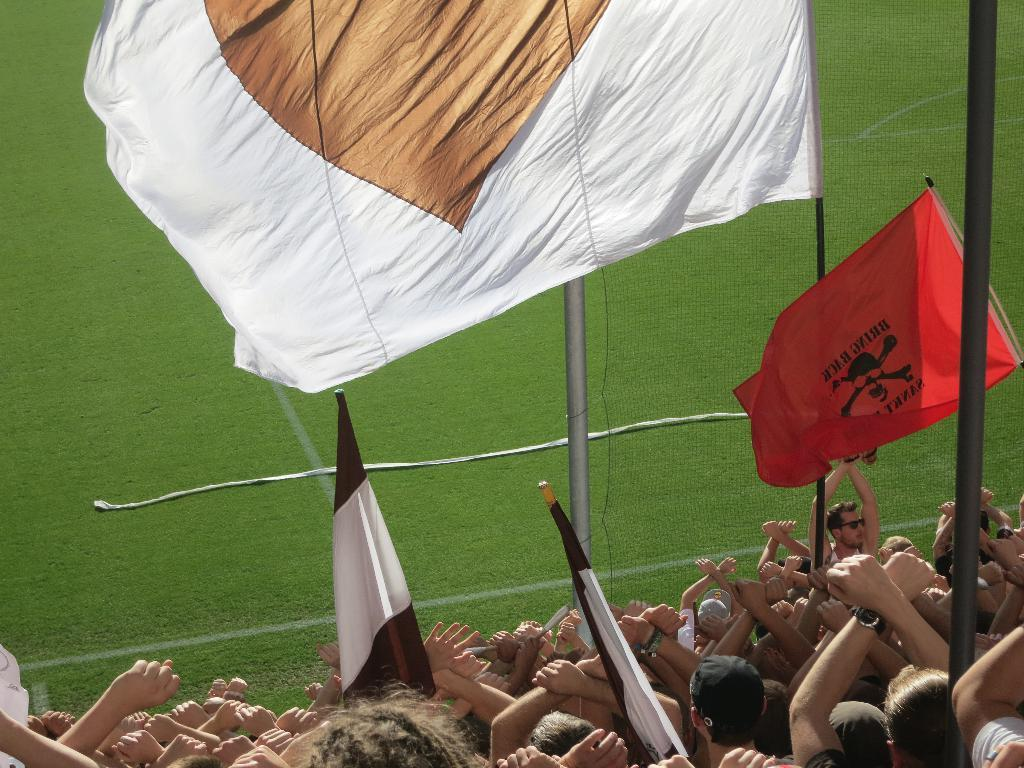What are the people in the image holding? The people in the image are holding flags. What can be seen supporting the flags in the image? There are poles in the image that support the flags. What type of surface is visible at the bottom of the image? There is grass on the surface at the bottom of the image. Where is the jewel hidden in the image? There is no jewel present in the image. Can you see a rake being used in the image? There is no rake visible in the image. 